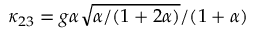Convert formula to latex. <formula><loc_0><loc_0><loc_500><loc_500>\kappa _ { 2 3 } = g \alpha \sqrt { \alpha / ( 1 + 2 \alpha ) } / ( 1 + \alpha )</formula> 